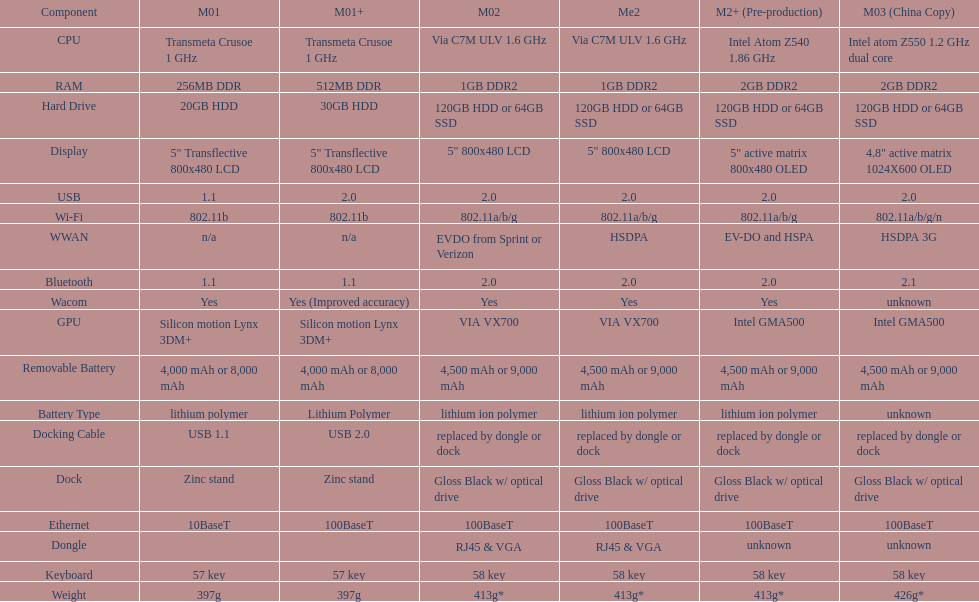Parse the full table. {'header': ['Component', 'M01', 'M01+', 'M02', 'Me2', 'M2+ (Pre-production)', 'M03 (China Copy)'], 'rows': [['CPU', 'Transmeta Crusoe 1\xa0GHz', 'Transmeta Crusoe 1\xa0GHz', 'Via C7M ULV 1.6\xa0GHz', 'Via C7M ULV 1.6\xa0GHz', 'Intel Atom Z540 1.86\xa0GHz', 'Intel atom Z550 1.2\xa0GHz dual core'], ['RAM', '256MB DDR', '512MB DDR', '1GB DDR2', '1GB DDR2', '2GB DDR2', '2GB DDR2'], ['Hard Drive', '20GB HDD', '30GB HDD', '120GB HDD or 64GB SSD', '120GB HDD or 64GB SSD', '120GB HDD or 64GB SSD', '120GB HDD or 64GB SSD'], ['Display', '5" Transflective 800x480 LCD', '5" Transflective 800x480 LCD', '5" 800x480 LCD', '5" 800x480 LCD', '5" active matrix 800x480 OLED', '4.8" active matrix 1024X600 OLED'], ['USB', '1.1', '2.0', '2.0', '2.0', '2.0', '2.0'], ['Wi-Fi', '802.11b', '802.11b', '802.11a/b/g', '802.11a/b/g', '802.11a/b/g', '802.11a/b/g/n'], ['WWAN', 'n/a', 'n/a', 'EVDO from Sprint or Verizon', 'HSDPA', 'EV-DO and HSPA', 'HSDPA 3G'], ['Bluetooth', '1.1', '1.1', '2.0', '2.0', '2.0', '2.1'], ['Wacom', 'Yes', 'Yes (Improved accuracy)', 'Yes', 'Yes', 'Yes', 'unknown'], ['GPU', 'Silicon motion Lynx 3DM+', 'Silicon motion Lynx 3DM+', 'VIA VX700', 'VIA VX700', 'Intel GMA500', 'Intel GMA500'], ['Removable Battery', '4,000 mAh or 8,000 mAh', '4,000 mAh or 8,000 mAh', '4,500 mAh or 9,000 mAh', '4,500 mAh or 9,000 mAh', '4,500 mAh or 9,000 mAh', '4,500 mAh or 9,000 mAh'], ['Battery Type', 'lithium polymer', 'Lithium Polymer', 'lithium ion polymer', 'lithium ion polymer', 'lithium ion polymer', 'unknown'], ['Docking Cable', 'USB 1.1', 'USB 2.0', 'replaced by dongle or dock', 'replaced by dongle or dock', 'replaced by dongle or dock', 'replaced by dongle or dock'], ['Dock', 'Zinc stand', 'Zinc stand', 'Gloss Black w/ optical drive', 'Gloss Black w/ optical drive', 'Gloss Black w/ optical drive', 'Gloss Black w/ optical drive'], ['Ethernet', '10BaseT', '100BaseT', '100BaseT', '100BaseT', '100BaseT', '100BaseT'], ['Dongle', '', '', 'RJ45 & VGA', 'RJ45 & VGA', 'unknown', 'unknown'], ['Keyboard', '57 key', '57 key', '58 key', '58 key', '58 key', '58 key'], ['Weight', '397g', '397g', '413g*', '413g*', '413g*', '426g*']]} What is the component before usb? Display. 